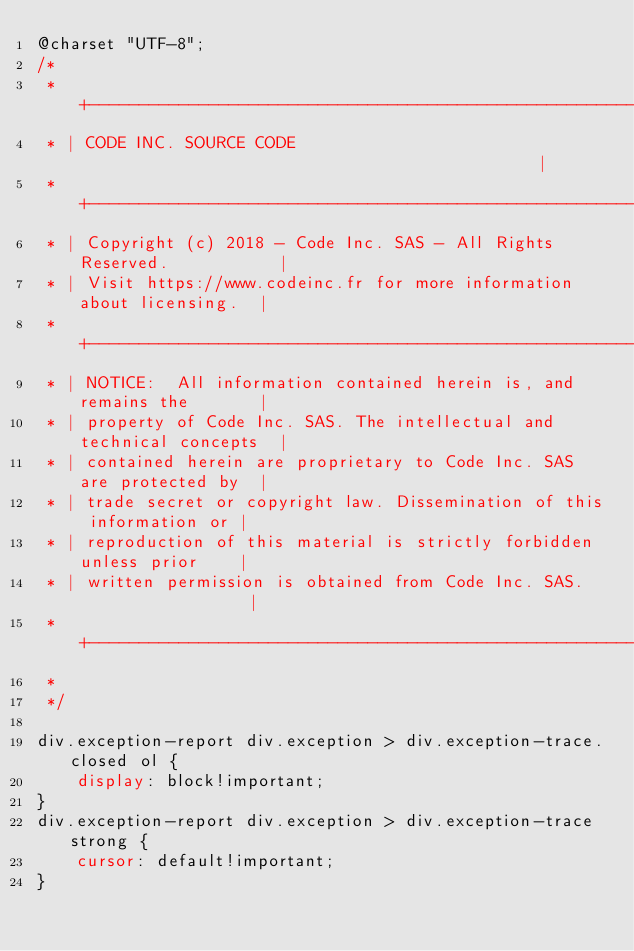Convert code to text. <code><loc_0><loc_0><loc_500><loc_500><_CSS_>@charset "UTF-8";
/*
 * +---------------------------------------------------------------------+
 * | CODE INC. SOURCE CODE                                               |
 * +---------------------------------------------------------------------+
 * | Copyright (c) 2018 - Code Inc. SAS - All Rights Reserved.           |
 * | Visit https://www.codeinc.fr for more information about licensing.  |
 * +---------------------------------------------------------------------+
 * | NOTICE:  All information contained herein is, and remains the       |
 * | property of Code Inc. SAS. The intellectual and technical concepts  |
 * | contained herein are proprietary to Code Inc. SAS are protected by  |
 * | trade secret or copyright law. Dissemination of this information or |
 * | reproduction of this material is strictly forbidden unless prior    |
 * | written permission is obtained from Code Inc. SAS.                  |
 * +---------------------------------------------------------------------+
 *
 */

div.exception-report div.exception > div.exception-trace.closed ol {
    display: block!important;
}
div.exception-report div.exception > div.exception-trace strong {
    cursor: default!important;
}</code> 